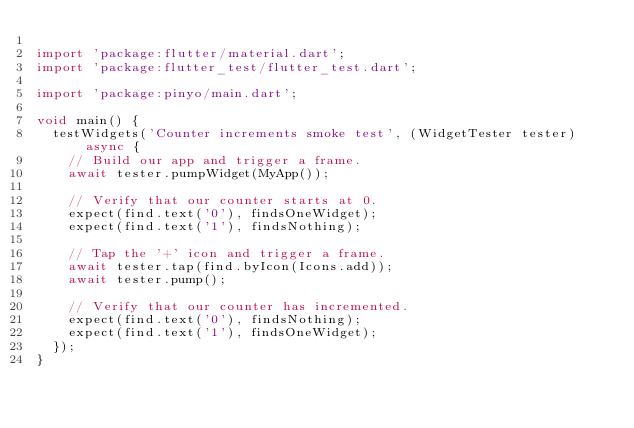<code> <loc_0><loc_0><loc_500><loc_500><_Dart_>
import 'package:flutter/material.dart';
import 'package:flutter_test/flutter_test.dart';

import 'package:pinyo/main.dart';

void main() {
  testWidgets('Counter increments smoke test', (WidgetTester tester) async {
    // Build our app and trigger a frame.
    await tester.pumpWidget(MyApp());

    // Verify that our counter starts at 0.
    expect(find.text('0'), findsOneWidget);
    expect(find.text('1'), findsNothing);

    // Tap the '+' icon and trigger a frame.
    await tester.tap(find.byIcon(Icons.add));
    await tester.pump();

    // Verify that our counter has incremented.
    expect(find.text('0'), findsNothing);
    expect(find.text('1'), findsOneWidget);
  });
}
</code> 